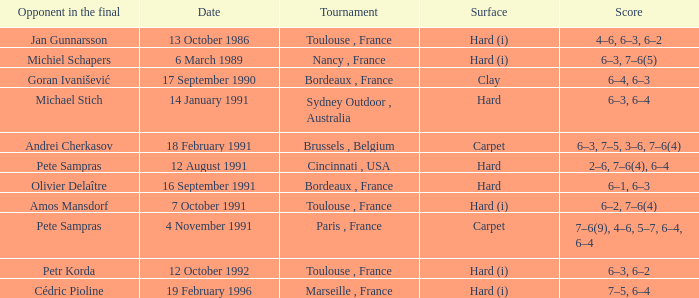What is the surface of the tournament with cédric pioline as the opponent in the final? Hard (i). 